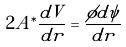<formula> <loc_0><loc_0><loc_500><loc_500>2 A ^ { \ast } \frac { d V } { d r } = \frac { \phi d \psi } { d r }</formula> 